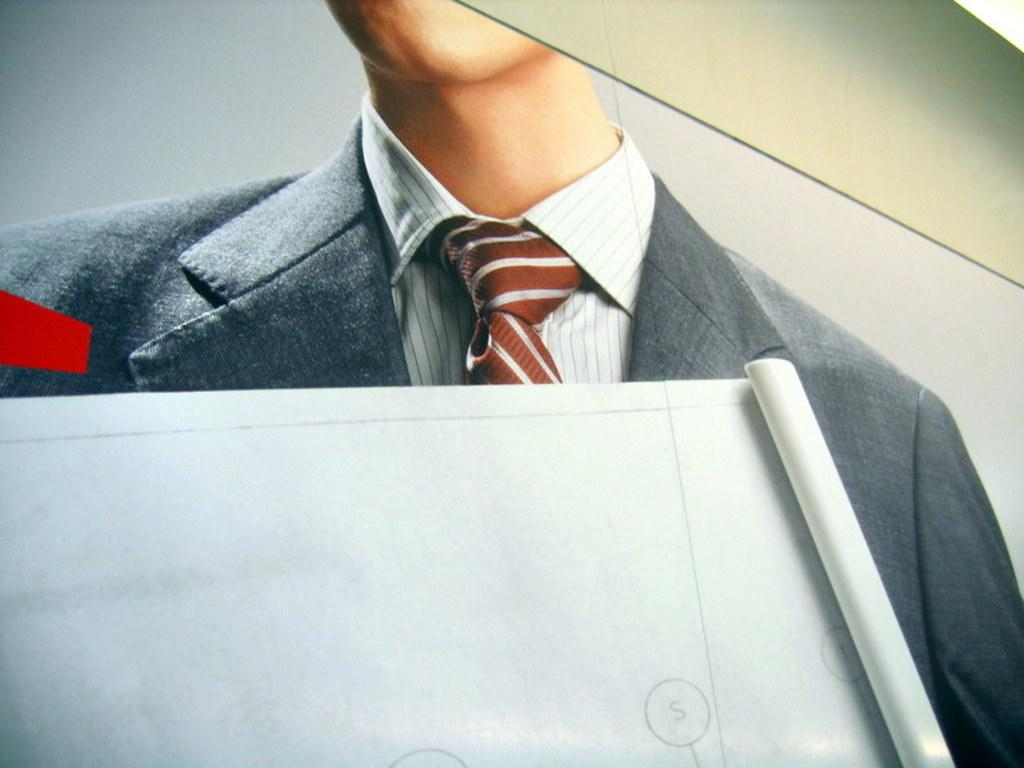What is the main subject of the image? There is a person in the image. What is the person wearing? The person is wearing a suit. What else can be seen in the image? There is a sheet in the image. What type of food is being served on the cars in the image? There are no cars or food present in the image; it only features a person wearing a suit and a sheet. 